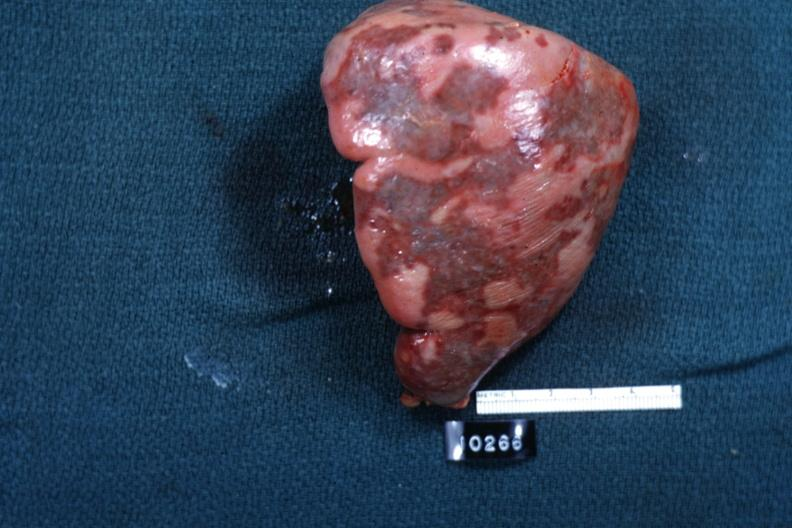what does this image show?
Answer the question using a single word or phrase. External view of spleen with multiple recent infarcts cut surface is slide 